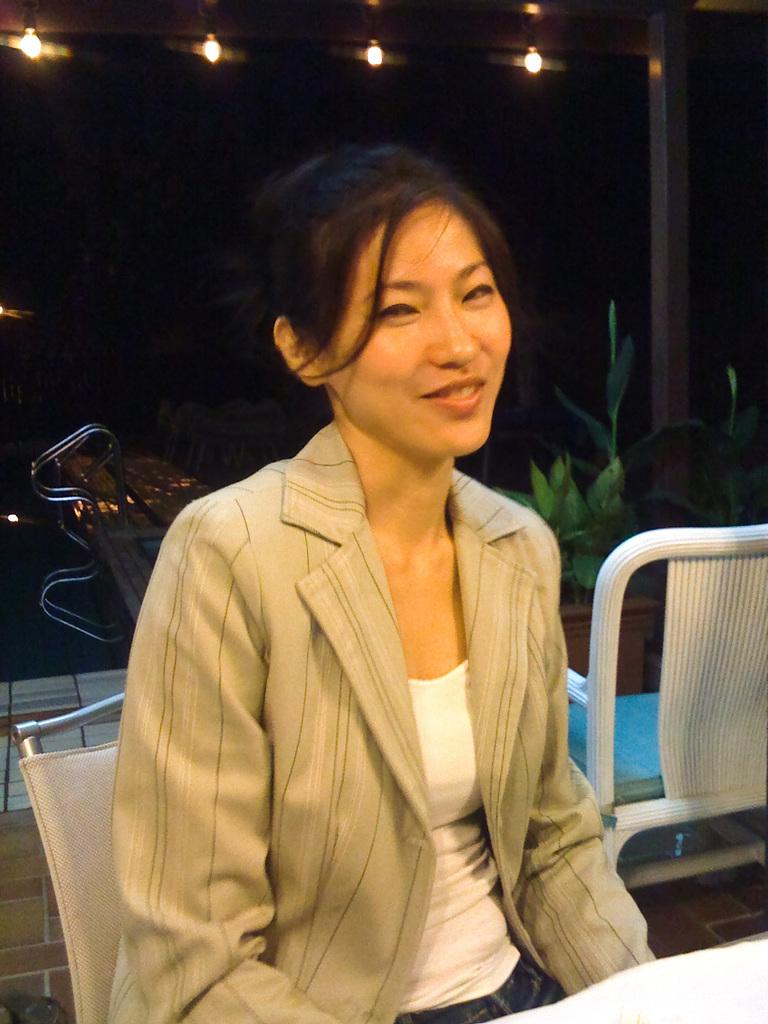Who is the main subject in the image? There is a woman in the image. What is the woman doing in the image? The woman is sitting on a chair. What can be seen behind the woman in the image? There is a swimming pool behind the woman. What type of location is the swimming pool part of? The swimming pool is part of a swim place. What advice does the woman give to the nation in the image? There is no indication in the image that the woman is giving advice to a nation. 